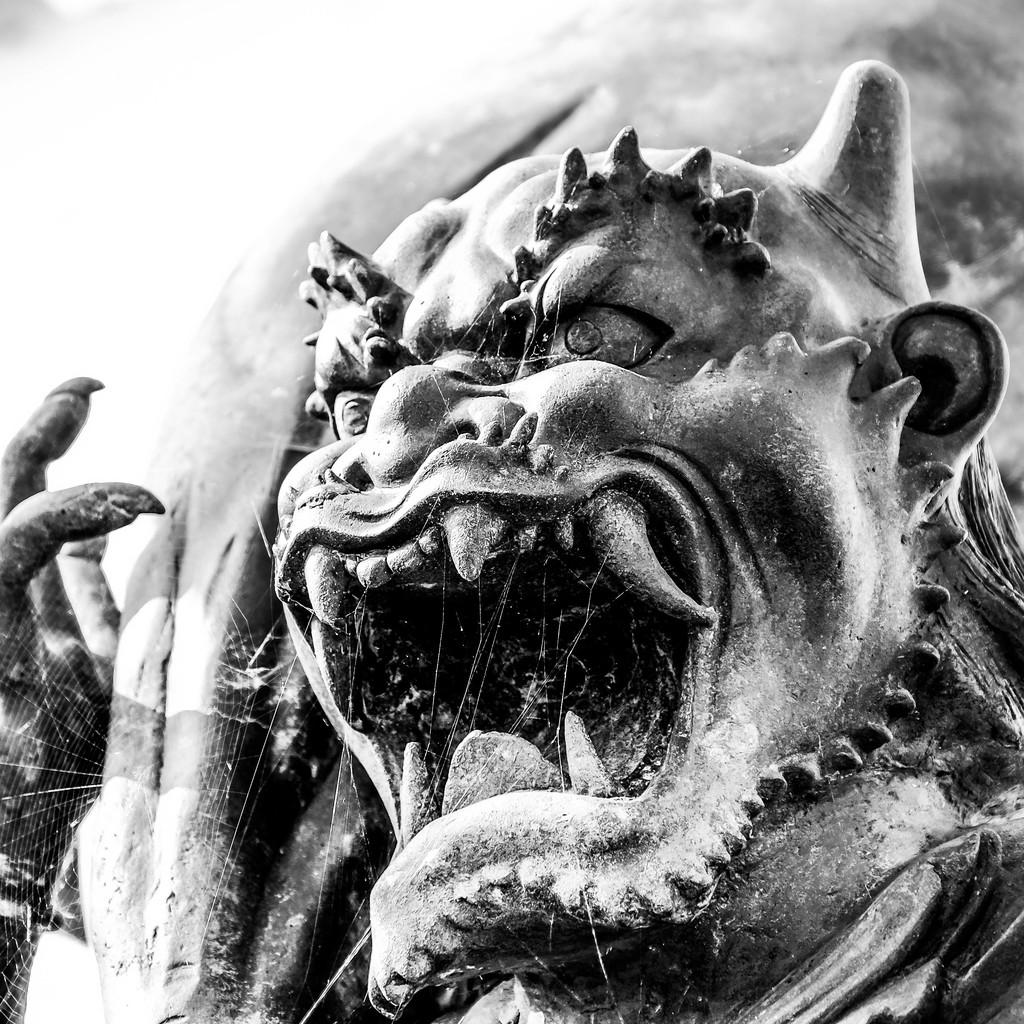What is the main subject in the image? There is a statue in the image. Are there any additional features or objects in the image? Yes, there is a spider web in the image. Can you describe the background of the image? The background of the image is not clear. What type of crown is the statue wearing in the image? There is no crown present on the statue in the image. How does the statue produce its own energy in the image? The statue does not produce its own energy in the image; it is a static object. 